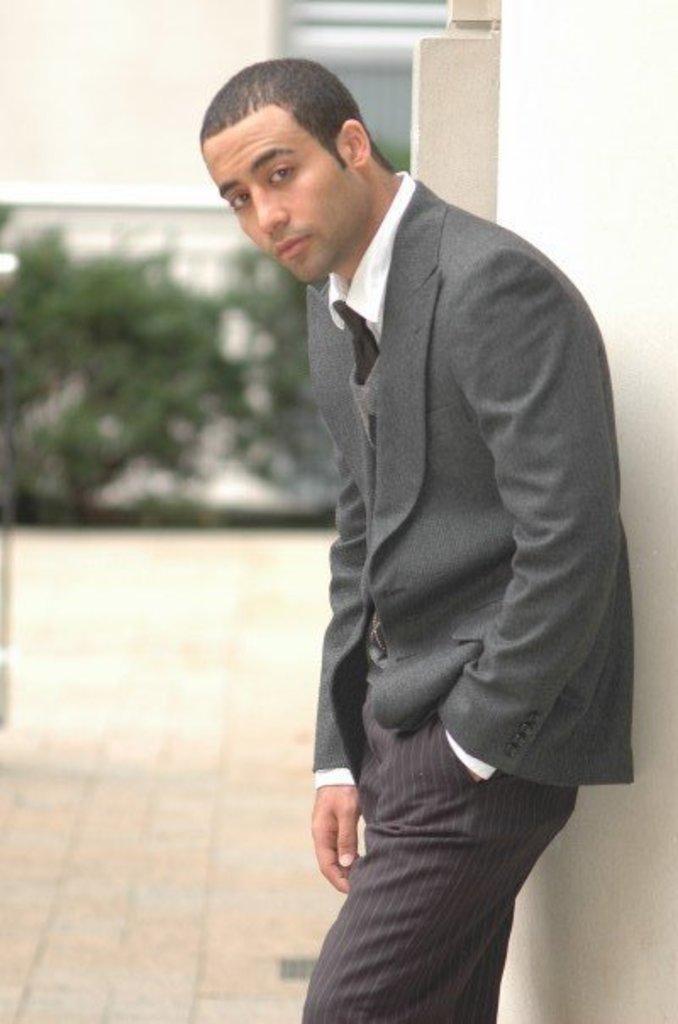In one or two sentences, can you explain what this image depicts? In this image we can see a man standing. He is wearing a suit. In the background there are plants and a wall. 